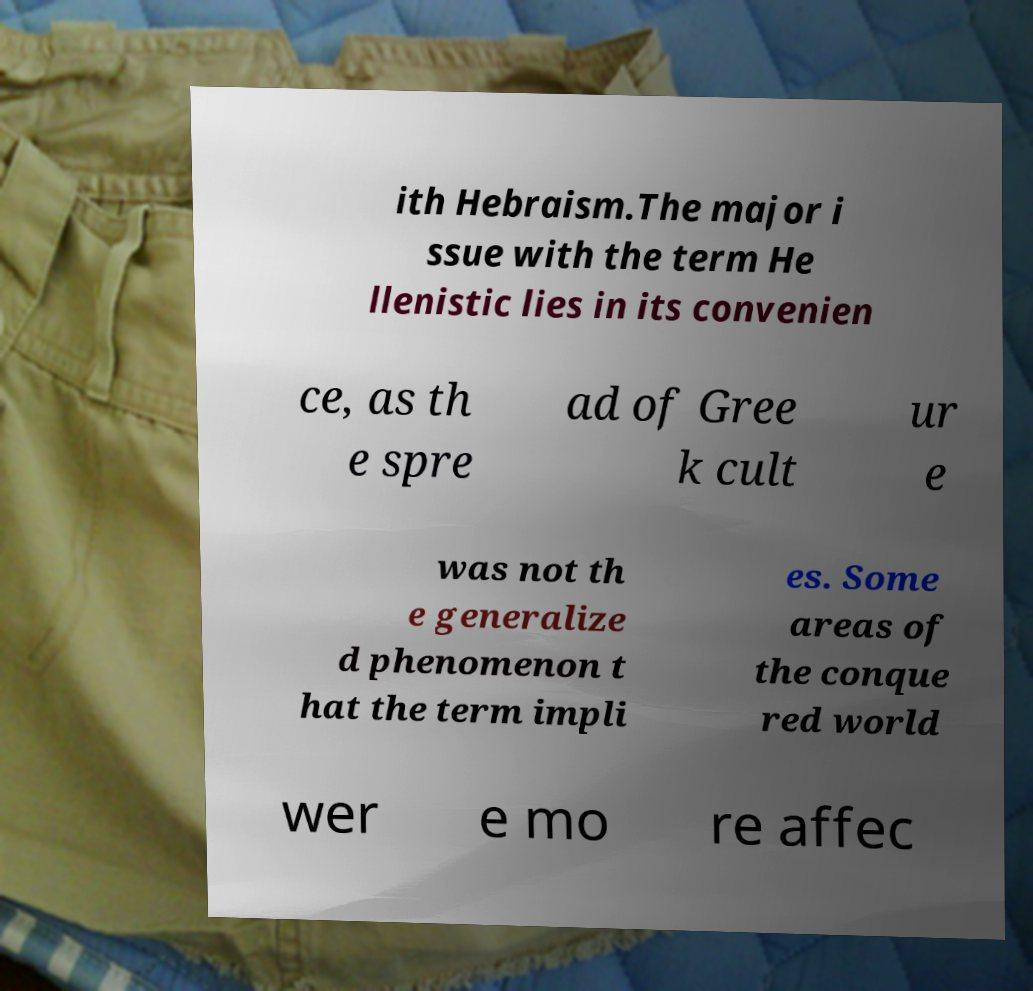Could you extract and type out the text from this image? ith Hebraism.The major i ssue with the term He llenistic lies in its convenien ce, as th e spre ad of Gree k cult ur e was not th e generalize d phenomenon t hat the term impli es. Some areas of the conque red world wer e mo re affec 